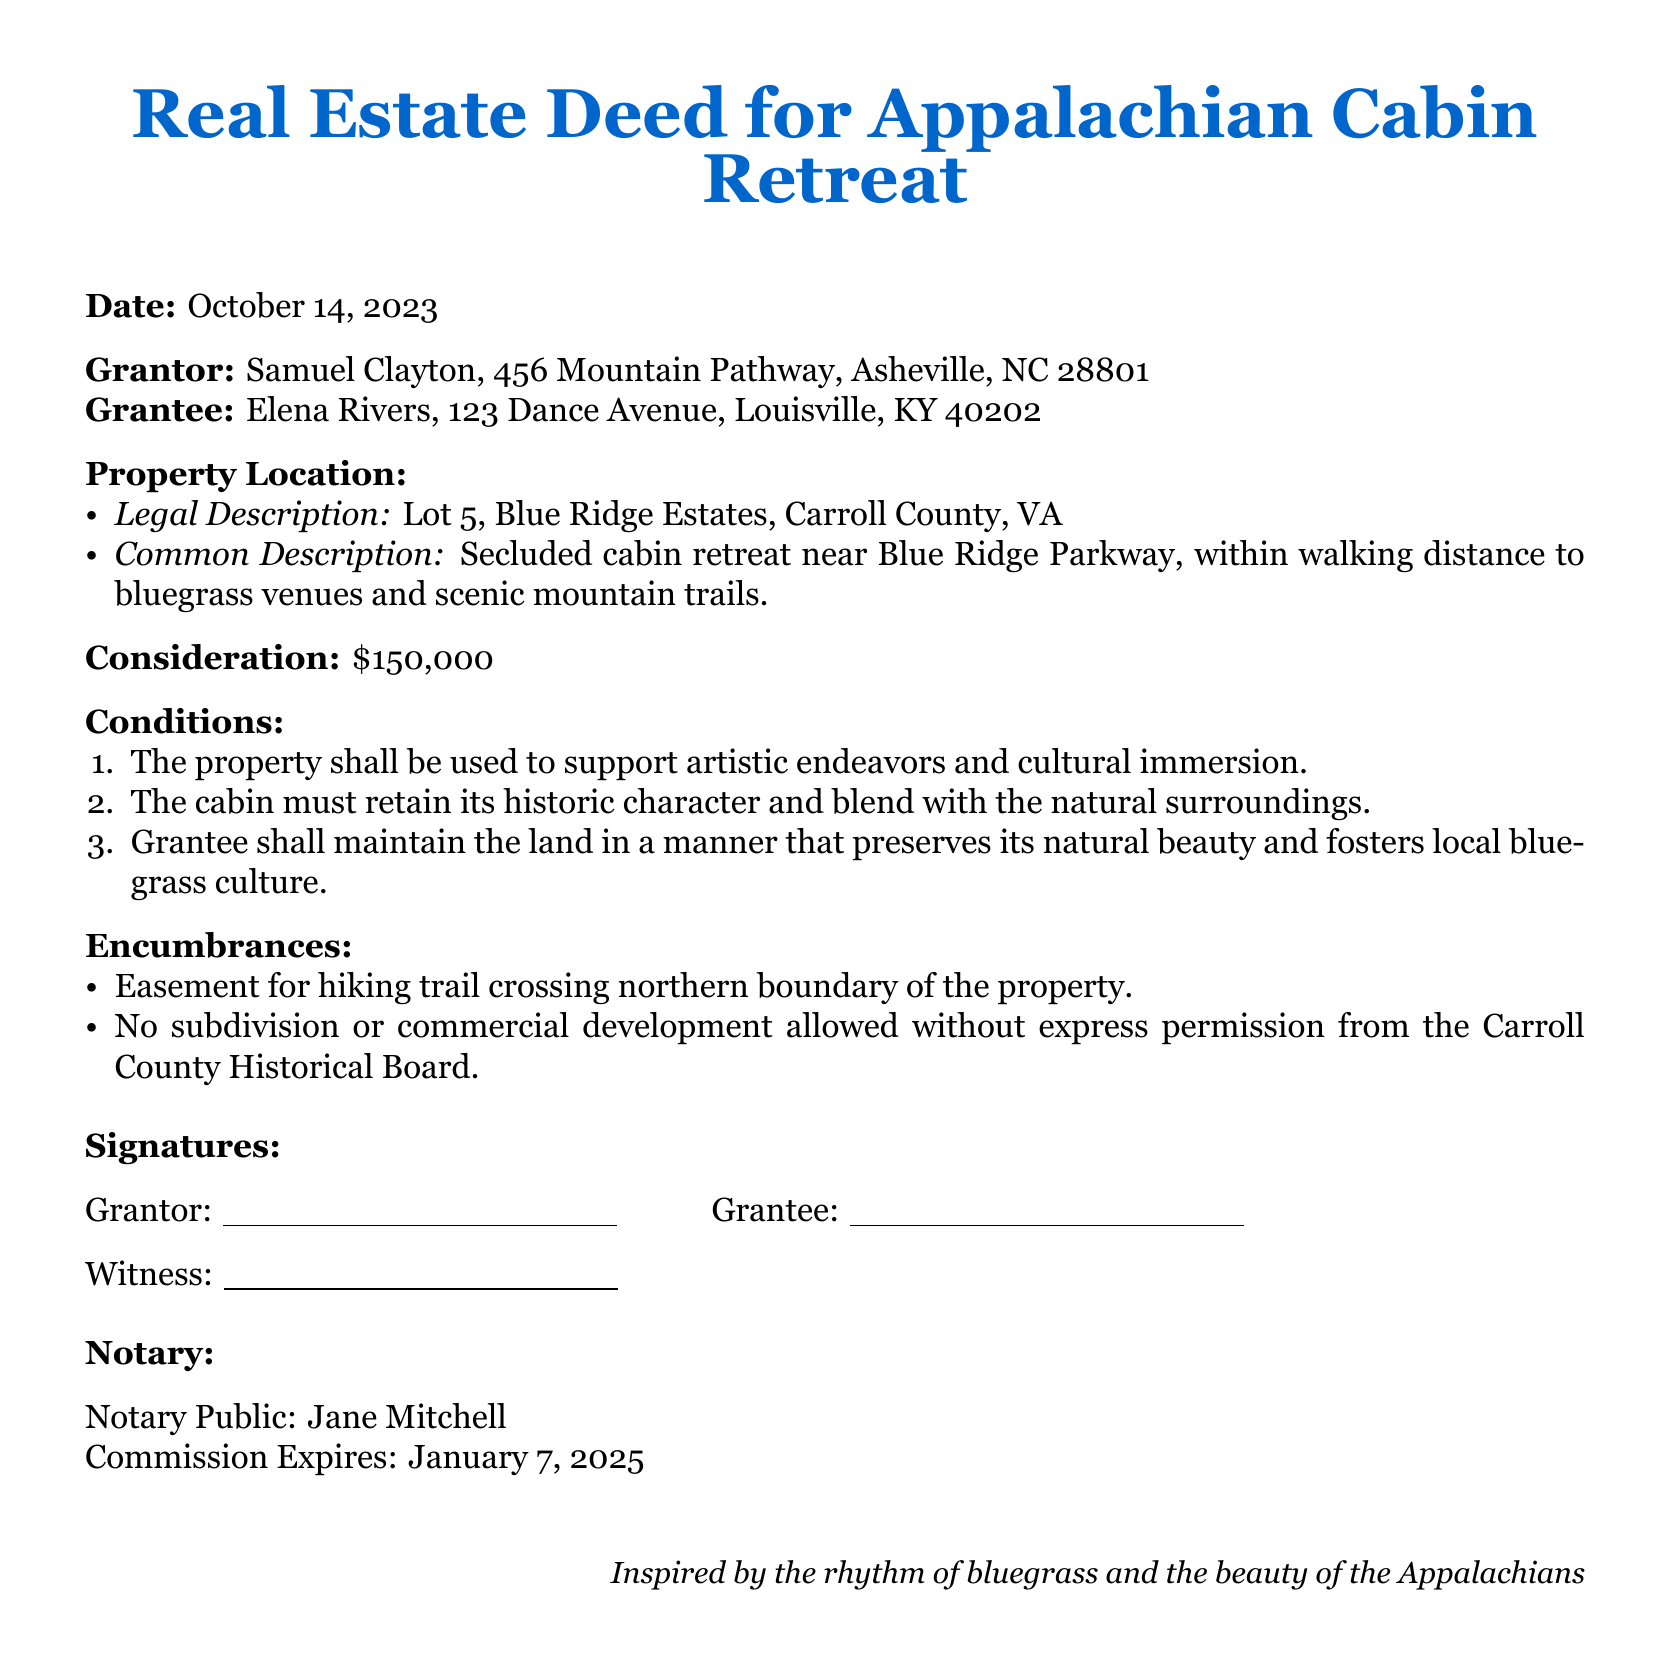what is the date of the deed? The date is explicitly mentioned at the beginning of the document.
Answer: October 14, 2023 who is the grantor of the property? The grantor's name is stated in the deed as the person transferring ownership.
Answer: Samuel Clayton what is the consideration amount for the property? The consideration amount is the price agreed upon for the property transfer.
Answer: $150,000 what is the legal description of the property? The legal description provides specific details about the real estate being transferred.
Answer: Lot 5, Blue Ridge Estates, Carroll County, VA what does the property need to retain according to its conditions? This condition indicates a requirement regarding the property’s appearance and character.
Answer: Historic character what is the common description of the property? The common description gives a brief overview of the property's characteristics and location.
Answer: Secluded cabin retreat near Blue Ridge Parkway who must approve subdivision or commercial development? This question pertains to regulatory oversight related to the property.
Answer: Carroll County Historical Board what is the name of the notary public? The notary public's name is required for the authenticity of the deed.
Answer: Jane Mitchell what must the grantee maintain according to the conditions? This highlights a responsibility assigned to the grantee regarding the preservation of the property.
Answer: Natural beauty 